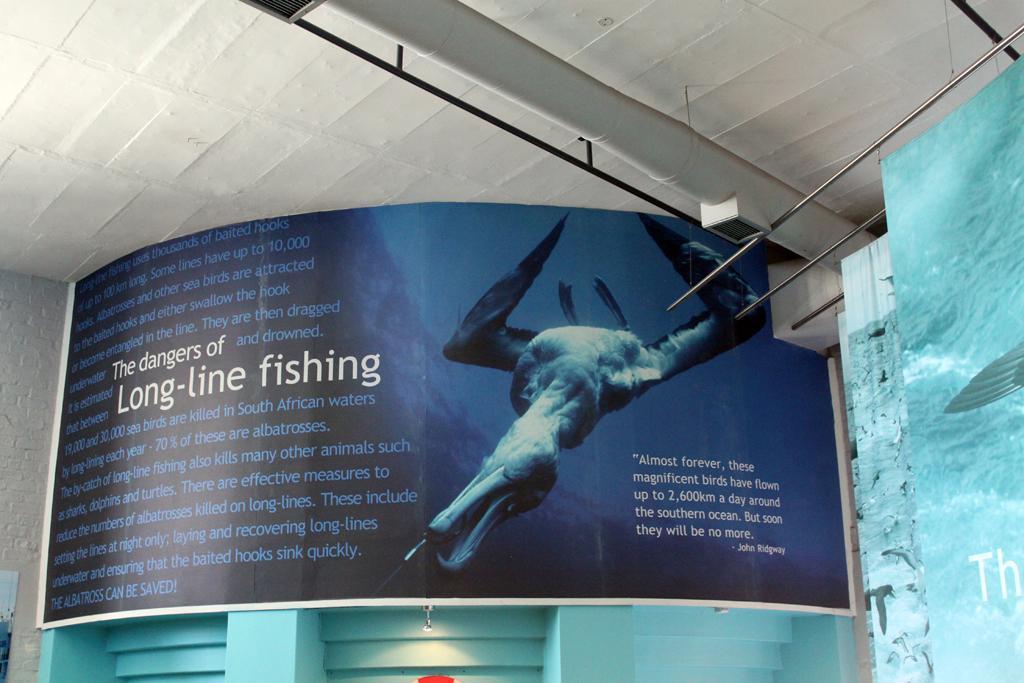Can you describe this image briefly? In this picture there is a banner which has an image and something written beside it and there are some other objects beside it. 